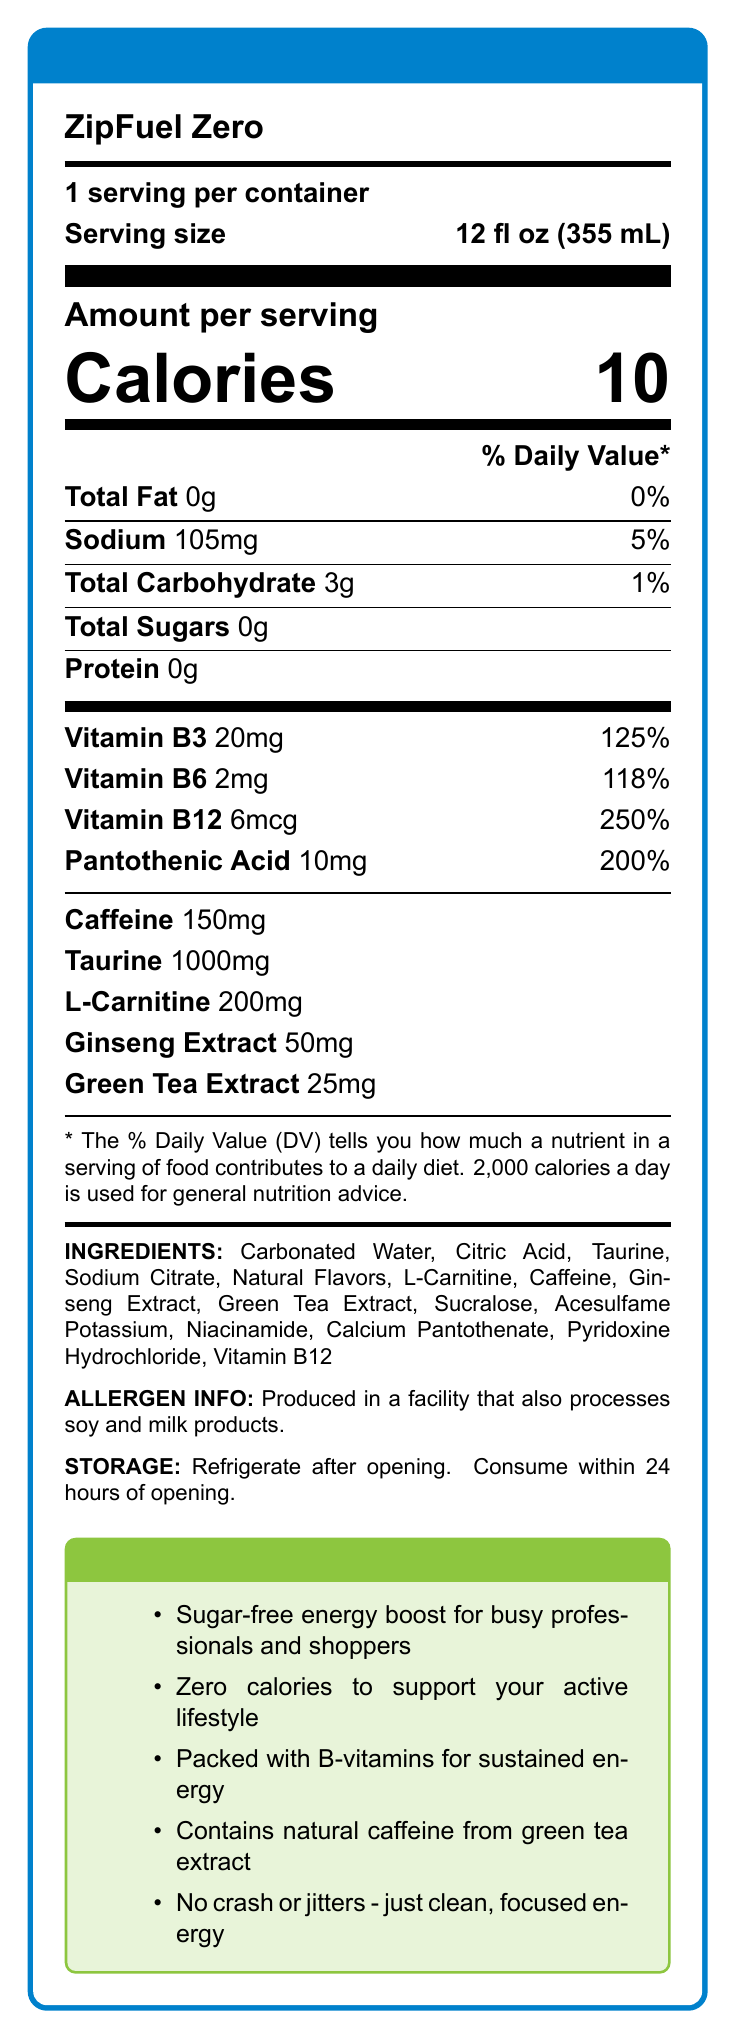How many calories are in a serving of ZipFuel Zero? The document clearly shows that there are 10 calories per serving of ZipFuel Zero.
Answer: 10 calories What is the serving size of ZipFuel Zero? The document lists the serving size as 12 fl oz (355 mL).
Answer: 12 fl oz (355 mL) How much sodium is in one serving of ZipFuel Zero? The nutrition facts label shows that there is 105mg of sodium per serving.
Answer: 105mg What is the caffeine content in one serving of ZipFuel Zero? Under the detailed nutrient information, it lists that one serving contains 150mg of caffeine.
Answer: 150mg What vitamins are included in ZipFuel Zero and their percentages of daily value? The document lists the specific vitamins in the product along with their percentages of the daily value.
Answer: Vitamin B3 (125%), Vitamin B6 (118%), Vitamin B12 (250%), Pantothenic Acid (200%) Which of the following ingredients is NOT found in ZipFuel Zero? A. Citric Acid B. Sucralose C. Fructose The ingredients list includes Citric Acid and Sucralose, but Fructose is not listed.
Answer: C What is the primary market target of ZipFuel Zero according to the marketing claims? A. Athletes B. Busy professionals and shoppers C. Students The claims specifically mention it is marketed towards "busy professionals and shoppers."
Answer: B Does ZipFuel Zero contain any sugar? The nutrition facts explicitly state that the product contains 0g of total sugars.
Answer: No Summarize the main idea of the ZipFuel Zero nutrition label. The document provides comprehensive details about the nutritional content, ingredients, and unique selling points of ZipFuel Zero, emphasizing its energy-boosting benefits and sugar-free formulation, aimed at busy individuals.
Answer: ZipFuel Zero is a sugar-free energy drink with 10 calories per serving, designed for busy professionals and shoppers. It contains B-vitamins, caffeine from green tea extract, and other ingredients to provide a sustained energy boost without a crash. The product is marketed towards those with an active lifestyle requiring focused energy. Are there any allergens mentioned in the nutrition label for ZipFuel Zero? The label indicates it is produced in a facility that processes soy and milk products.
Answer: Yes What ingredient in ZipFuel Zero is used as a sweetener? The ingredients list includes Sucralose, which is a common artificial sweetener.
Answer: Sucralose What are the storage instructions for ZipFuel Zero? The document explicitly states these storage instructions.
Answer: Refrigerate after opening. Consume within 24 hours of opening. Can you determine the price of ZipFuel Zero based on the document? The nutrition label and description do not provide any details regarding the cost of ZipFuel Zero.
Answer: Not enough information 